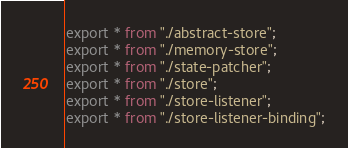Convert code to text. <code><loc_0><loc_0><loc_500><loc_500><_TypeScript_>export * from "./abstract-store";
export * from "./memory-store";
export * from "./state-patcher";
export * from "./store";
export * from "./store-listener";
export * from "./store-listener-binding";
</code> 